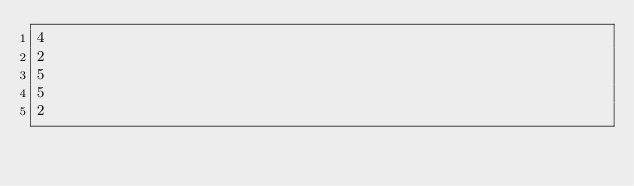<code> <loc_0><loc_0><loc_500><loc_500><_Python_>4
2
5
5
2</code> 